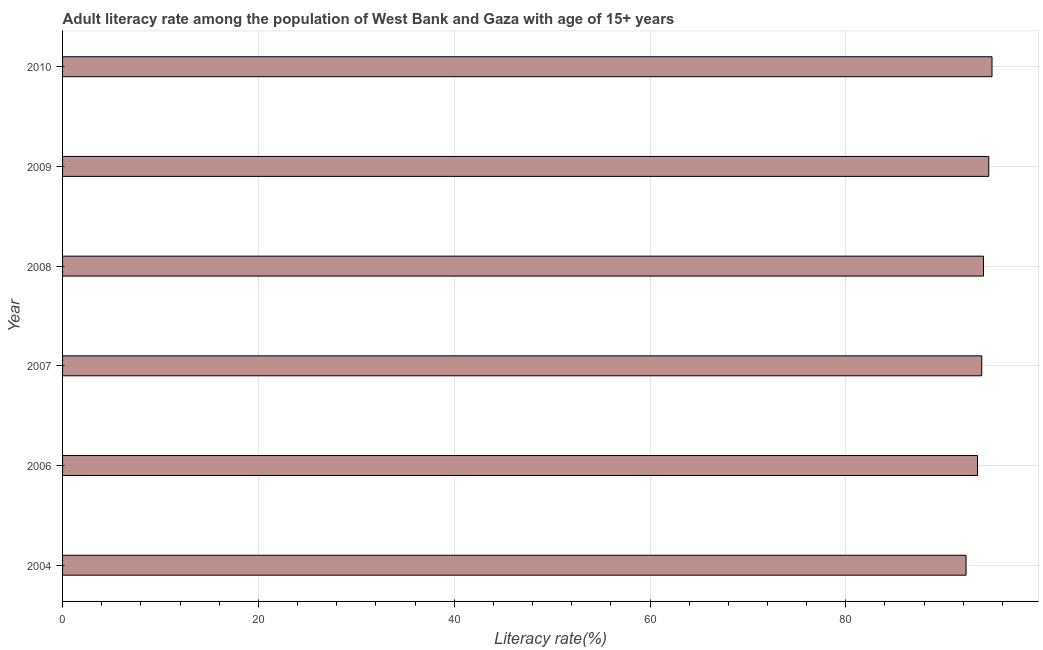Does the graph contain any zero values?
Provide a succinct answer. No. Does the graph contain grids?
Provide a succinct answer. Yes. What is the title of the graph?
Offer a very short reply. Adult literacy rate among the population of West Bank and Gaza with age of 15+ years. What is the label or title of the X-axis?
Your answer should be very brief. Literacy rate(%). What is the label or title of the Y-axis?
Offer a very short reply. Year. What is the adult literacy rate in 2006?
Ensure brevity in your answer.  93.45. Across all years, what is the maximum adult literacy rate?
Provide a succinct answer. 94.93. Across all years, what is the minimum adult literacy rate?
Offer a very short reply. 92.28. In which year was the adult literacy rate maximum?
Offer a very short reply. 2010. What is the sum of the adult literacy rate?
Provide a succinct answer. 563.2. What is the difference between the adult literacy rate in 2006 and 2007?
Make the answer very short. -0.43. What is the average adult literacy rate per year?
Ensure brevity in your answer.  93.87. What is the median adult literacy rate?
Provide a short and direct response. 93.97. In how many years, is the adult literacy rate greater than 80 %?
Your answer should be very brief. 6. Is the adult literacy rate in 2006 less than that in 2009?
Keep it short and to the point. Yes. Is the difference between the adult literacy rate in 2009 and 2010 greater than the difference between any two years?
Make the answer very short. No. What is the difference between the highest and the second highest adult literacy rate?
Your answer should be very brief. 0.33. Is the sum of the adult literacy rate in 2004 and 2009 greater than the maximum adult literacy rate across all years?
Your answer should be very brief. Yes. What is the difference between the highest and the lowest adult literacy rate?
Give a very brief answer. 2.65. In how many years, is the adult literacy rate greater than the average adult literacy rate taken over all years?
Make the answer very short. 4. How many bars are there?
Your answer should be compact. 6. What is the difference between two consecutive major ticks on the X-axis?
Offer a very short reply. 20. What is the Literacy rate(%) in 2004?
Offer a very short reply. 92.28. What is the Literacy rate(%) in 2006?
Keep it short and to the point. 93.45. What is the Literacy rate(%) in 2007?
Offer a very short reply. 93.88. What is the Literacy rate(%) in 2008?
Your answer should be compact. 94.06. What is the Literacy rate(%) of 2009?
Your answer should be compact. 94.6. What is the Literacy rate(%) of 2010?
Give a very brief answer. 94.93. What is the difference between the Literacy rate(%) in 2004 and 2006?
Ensure brevity in your answer.  -1.17. What is the difference between the Literacy rate(%) in 2004 and 2007?
Your response must be concise. -1.6. What is the difference between the Literacy rate(%) in 2004 and 2008?
Provide a short and direct response. -1.78. What is the difference between the Literacy rate(%) in 2004 and 2009?
Ensure brevity in your answer.  -2.32. What is the difference between the Literacy rate(%) in 2004 and 2010?
Ensure brevity in your answer.  -2.65. What is the difference between the Literacy rate(%) in 2006 and 2007?
Provide a short and direct response. -0.43. What is the difference between the Literacy rate(%) in 2006 and 2008?
Make the answer very short. -0.61. What is the difference between the Literacy rate(%) in 2006 and 2009?
Your answer should be very brief. -1.15. What is the difference between the Literacy rate(%) in 2006 and 2010?
Keep it short and to the point. -1.48. What is the difference between the Literacy rate(%) in 2007 and 2008?
Ensure brevity in your answer.  -0.18. What is the difference between the Literacy rate(%) in 2007 and 2009?
Provide a short and direct response. -0.72. What is the difference between the Literacy rate(%) in 2007 and 2010?
Provide a short and direct response. -1.05. What is the difference between the Literacy rate(%) in 2008 and 2009?
Provide a succinct answer. -0.54. What is the difference between the Literacy rate(%) in 2008 and 2010?
Your answer should be compact. -0.87. What is the difference between the Literacy rate(%) in 2009 and 2010?
Ensure brevity in your answer.  -0.33. What is the ratio of the Literacy rate(%) in 2004 to that in 2008?
Your response must be concise. 0.98. What is the ratio of the Literacy rate(%) in 2006 to that in 2007?
Offer a terse response. 0.99. What is the ratio of the Literacy rate(%) in 2006 to that in 2008?
Your response must be concise. 0.99. What is the ratio of the Literacy rate(%) in 2007 to that in 2009?
Your answer should be very brief. 0.99. 